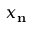Convert formula to latex. <formula><loc_0><loc_0><loc_500><loc_500>x _ { n }</formula> 